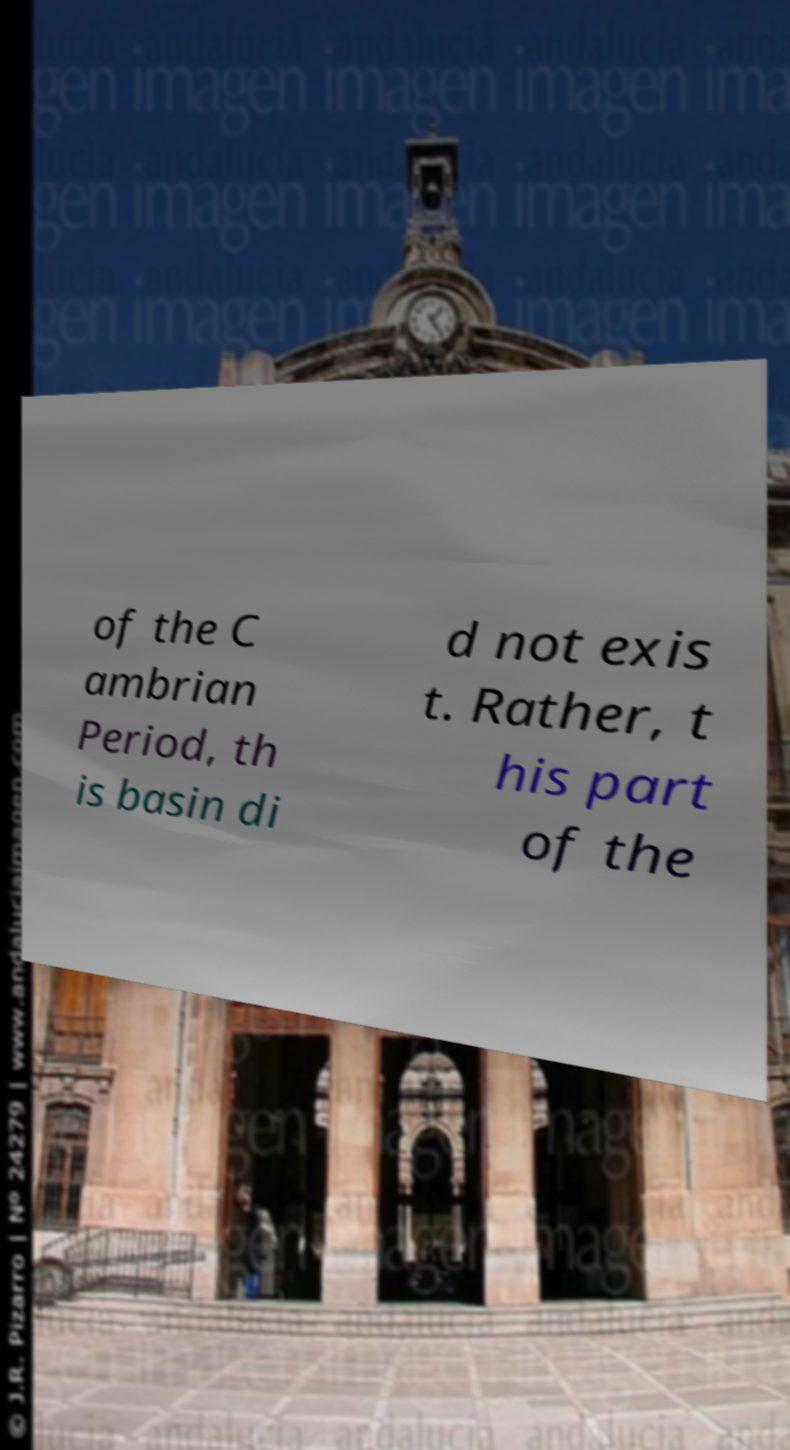There's text embedded in this image that I need extracted. Can you transcribe it verbatim? of the C ambrian Period, th is basin di d not exis t. Rather, t his part of the 